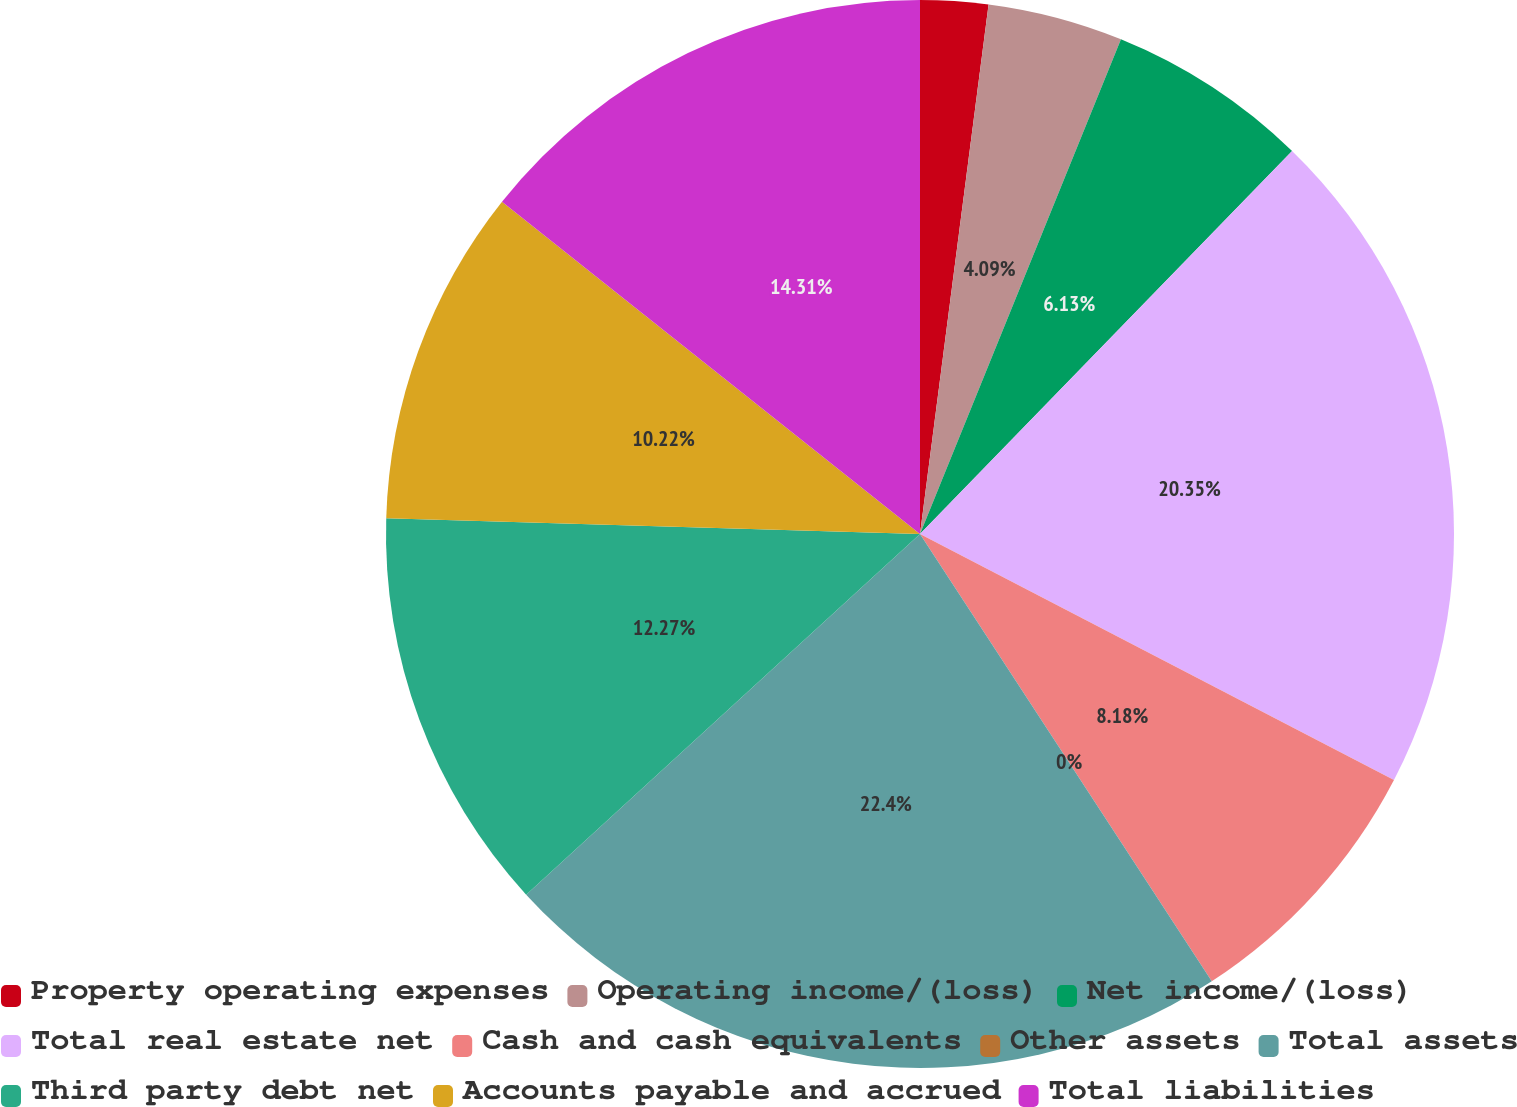Convert chart to OTSL. <chart><loc_0><loc_0><loc_500><loc_500><pie_chart><fcel>Property operating expenses<fcel>Operating income/(loss)<fcel>Net income/(loss)<fcel>Total real estate net<fcel>Cash and cash equivalents<fcel>Other assets<fcel>Total assets<fcel>Third party debt net<fcel>Accounts payable and accrued<fcel>Total liabilities<nl><fcel>2.05%<fcel>4.09%<fcel>6.13%<fcel>20.35%<fcel>8.18%<fcel>0.0%<fcel>22.4%<fcel>12.27%<fcel>10.22%<fcel>14.31%<nl></chart> 